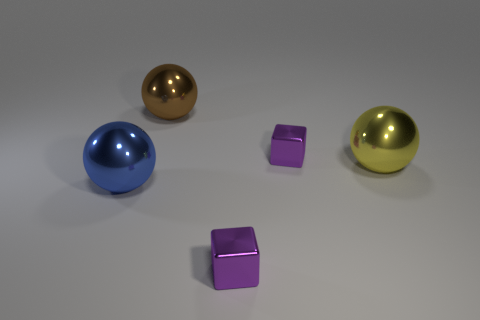Add 2 large yellow metallic spheres. How many objects exist? 7 Subtract all balls. How many objects are left? 2 Add 4 yellow spheres. How many yellow spheres are left? 5 Add 1 small objects. How many small objects exist? 3 Subtract 0 cyan spheres. How many objects are left? 5 Subtract all big gray matte spheres. Subtract all brown metal spheres. How many objects are left? 4 